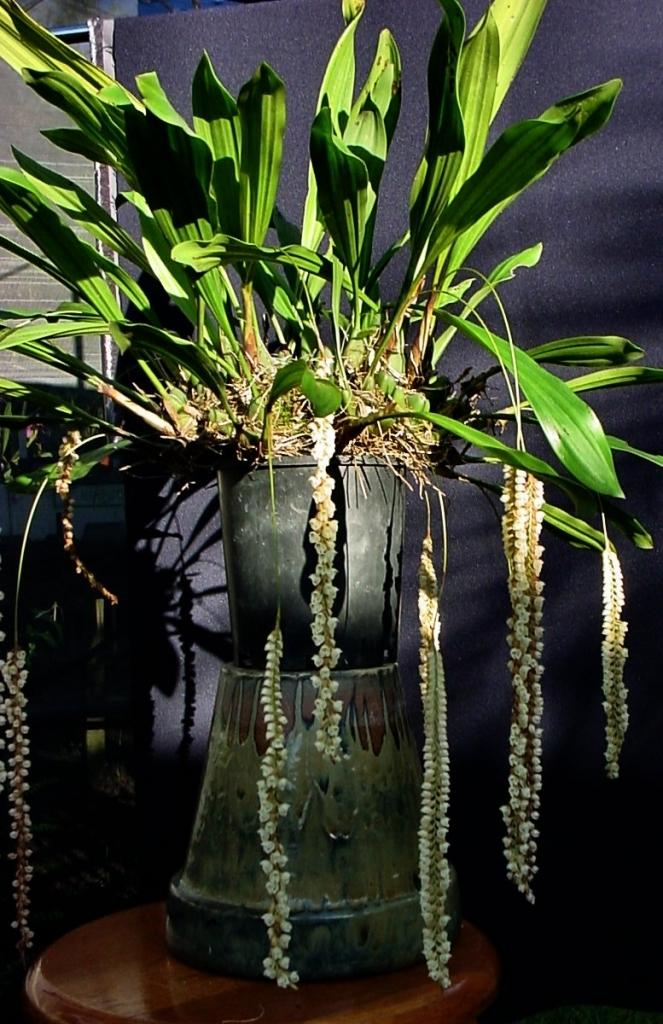What object is present in the image that is used for holding plants? There is a plant pot in the image. Where is the plant pot located? The plant pot is placed on a table. What can be seen in the background of the image? There is a curtain in the background of the image. What type of harmony is being discussed in the meeting taking place in the image? There is no meeting or discussion of harmony present in the image; it features a plant pot on a table with a curtain in the background. 